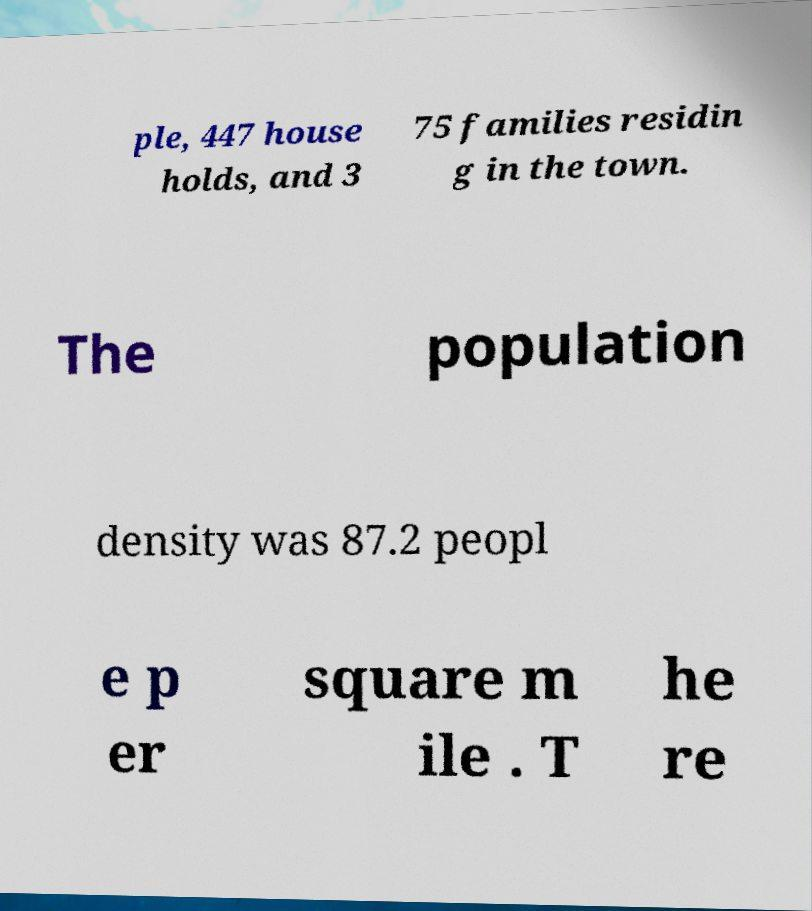There's text embedded in this image that I need extracted. Can you transcribe it verbatim? ple, 447 house holds, and 3 75 families residin g in the town. The population density was 87.2 peopl e p er square m ile . T he re 